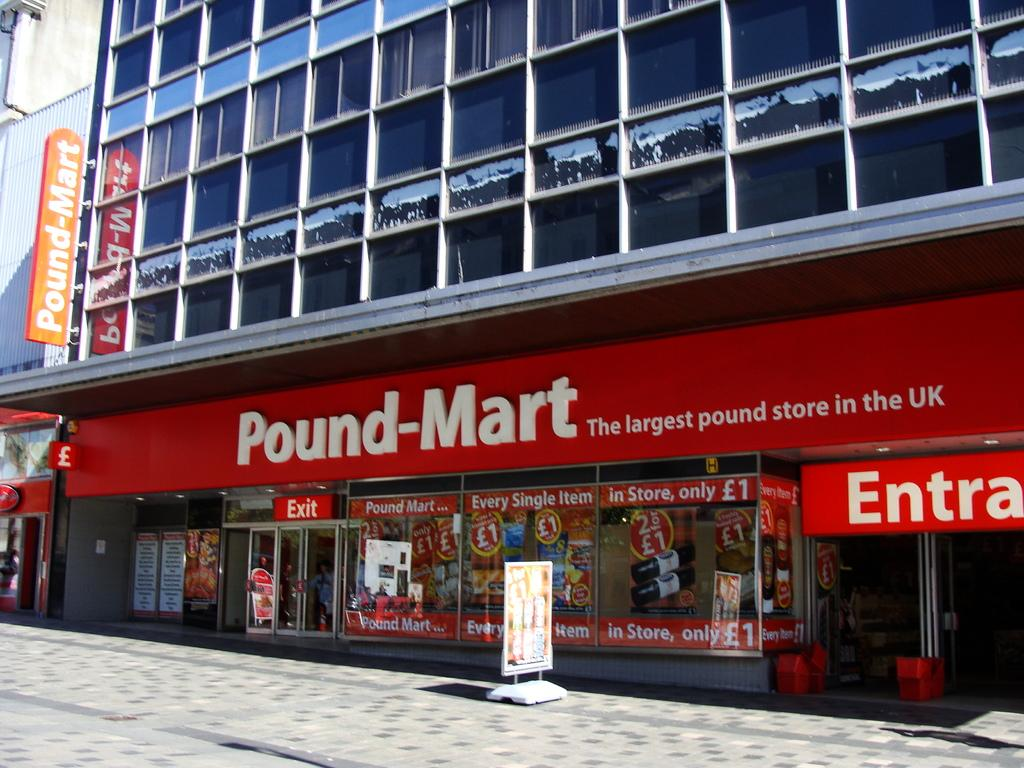What is the main structure in the center of the image? There is a building in the center of the image. What features can be observed on the building? The building has windows, banners, and glass doors. What is the name of the building in the image? The building is labeled as "Pound Mart". What else can be seen in the image besides the building? There is a road visible in the image. What type of teeth can be seen on the banners in the image? There are no teeth present on the banners in the image. What historical event is depicted in the image? There is no historical event depicted in the image; it features a building with banners and a road. 